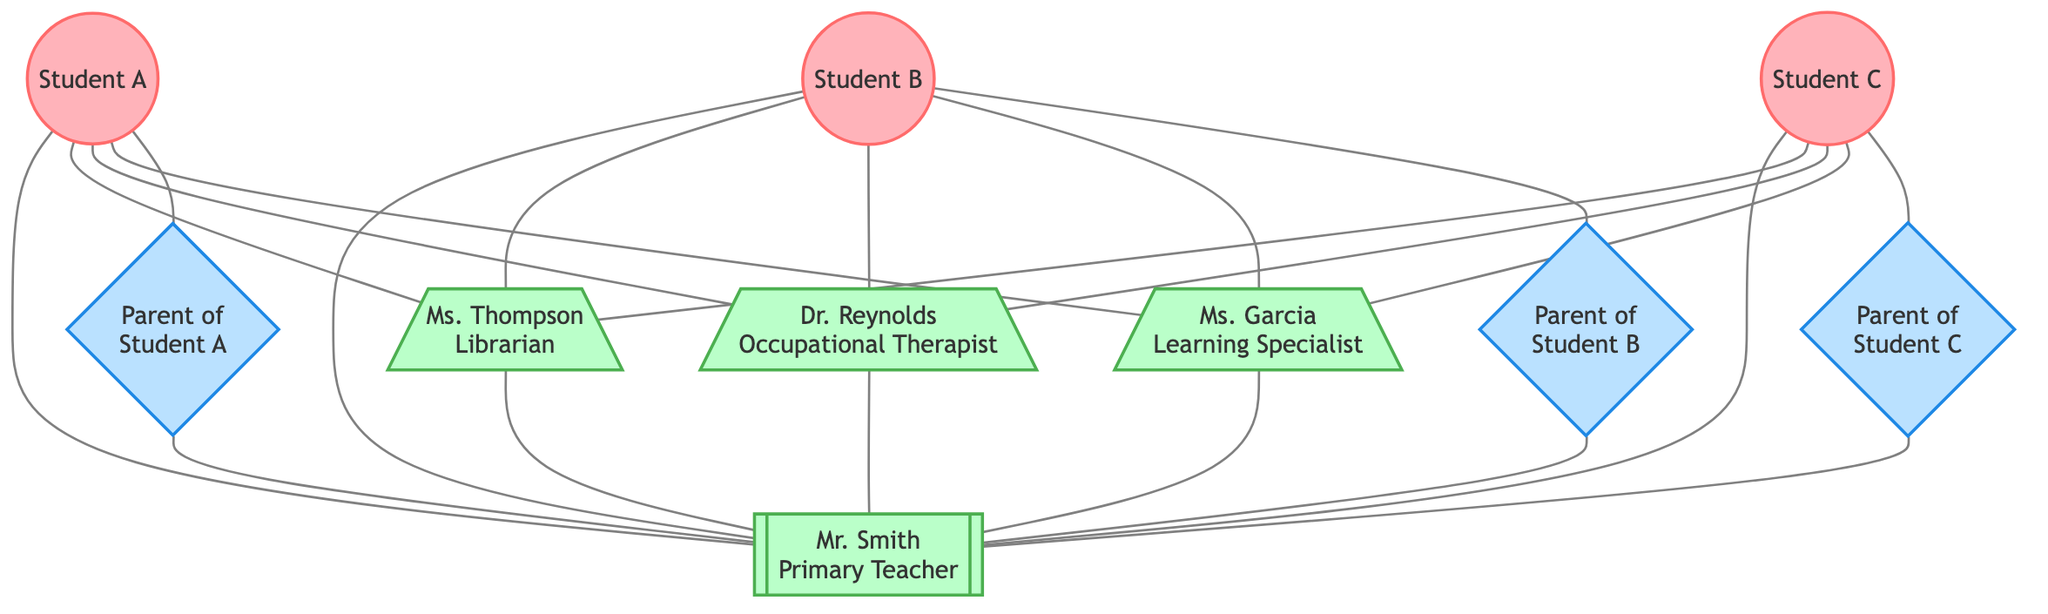What's the total number of nodes in the diagram? The diagram includes various nodes such as students, a teacher, a librarian, an occupational therapist, a learning specialist, and parents. By counting these, we find there are 10 distinct nodes in total.
Answer: 10 How many parents are represented in the diagram? The diagram displays three parents: Parent of Student A, Parent of Student B, and Parent of Student C. Counting these gives us a total of three parents.
Answer: 3 Which role is connected to all students in the diagram? By examining the connections, we can see that each student is linked to the teacher. The edges between students and the teacher confirm this relationship.
Answer: Teacher What is the relationship between the librarian and the teacher? The diagram indicates a direct connection (edge) from the librarian to the teacher, signifying a professional relationship between the two.
Answer: Professional relationship How many distinct types of roles are represented in the diagram? The diagram illustrates four distinct roles: Diverse Learner, Primary Teacher, Librarian, Occupational Therapist, and Learning Specialist, which totals to five types of roles.
Answer: 5 How many connections does each student have? Each student is connected to five entities: the teacher, librarian, occupational therapist, learning specialist, and their respective parent. Therefore, there are five connections per student.
Answer: 5 Which two nodes share a connection with all three students? Analyzing the edges, the nodes of the teacher and librarian are connected to all three students, indicating that both play a significant role in supporting them.
Answer: Teacher and Librarian How many edges connect parents to the teacher? Each parent in the diagram has an edge connecting them directly to the teacher, resulting in three edges total from the three parents to the teacher.
Answer: 3 What roles do the students rely on for their social support? The students rely on several roles for social support, which include their parents, teacher, librarian, occupational therapist, and learning specialist. Each of these connections emphasizes the importance of collaboration for student success.
Answer: Parents, Teacher, Librarian, Occupational Therapist, Learning Specialist 